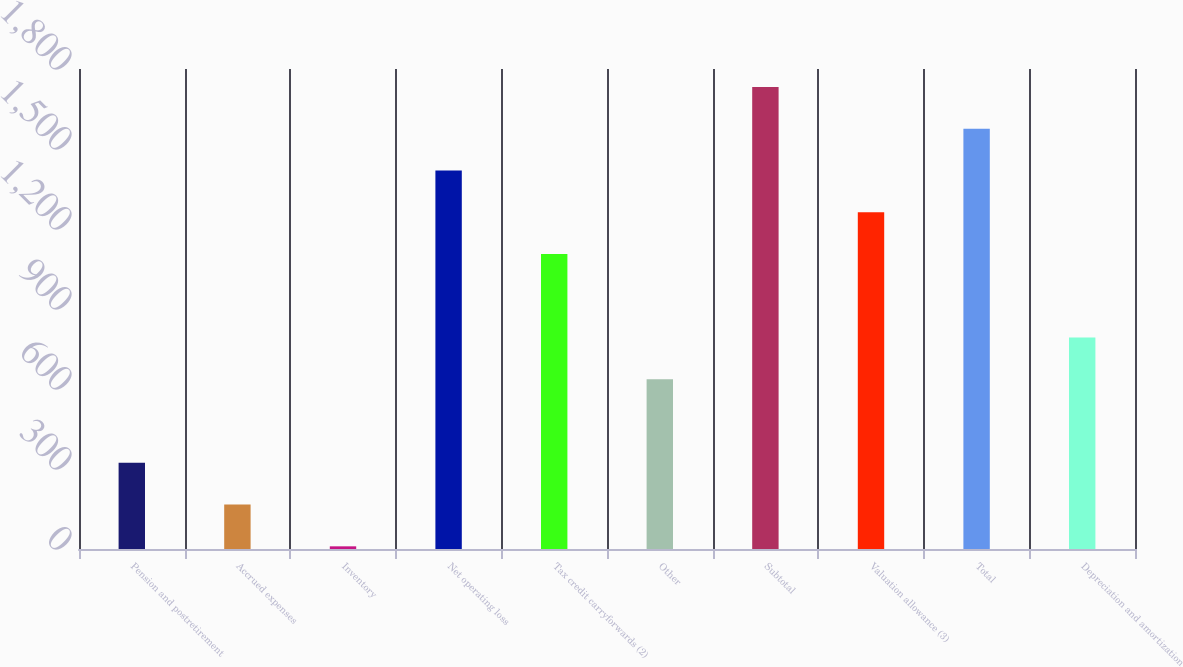<chart> <loc_0><loc_0><loc_500><loc_500><bar_chart><fcel>Pension and postretirement<fcel>Accrued expenses<fcel>Inventory<fcel>Net operating loss<fcel>Tax credit carryforwards (2)<fcel>Other<fcel>Subtotal<fcel>Valuation allowance (3)<fcel>Total<fcel>Depreciation and amortization<nl><fcel>323.2<fcel>166.6<fcel>10<fcel>1419.4<fcel>1106.2<fcel>636.4<fcel>1732.6<fcel>1262.8<fcel>1576<fcel>793<nl></chart> 